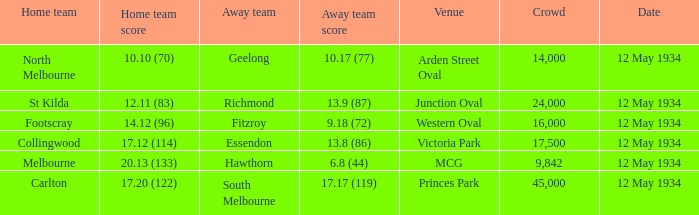What place had an Away team get a score of 10.17 (77)? Arden Street Oval. 